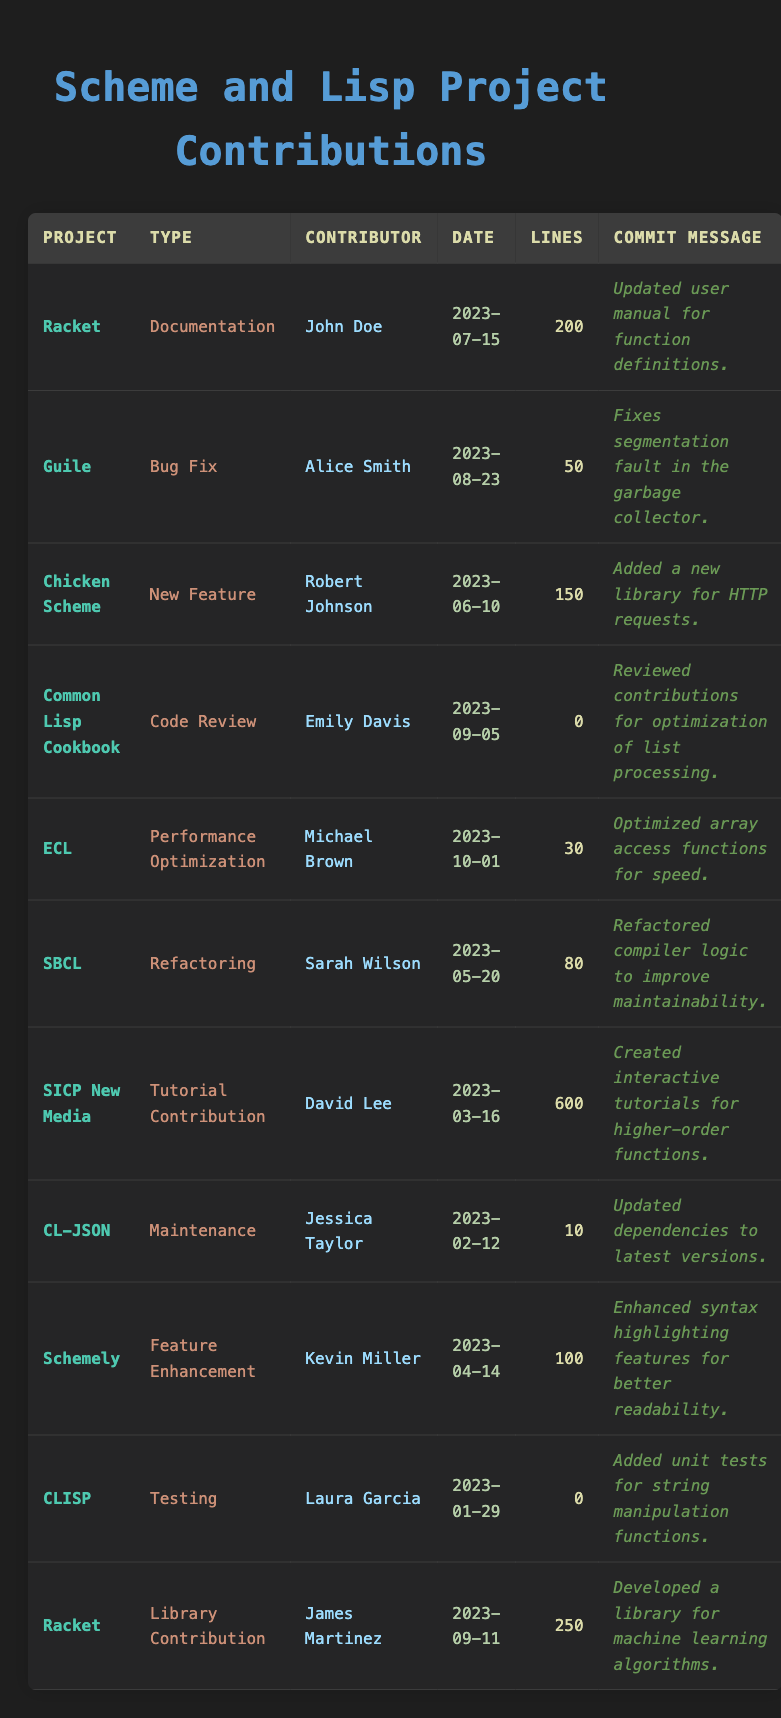What is the total number of lines contributed to the Racket project? The Racket project has two contributions: one with 200 lines and another with 250 lines. Adding these gives 200 + 250 = 450 lines of code contributed to the Racket project.
Answer: 450 Who contributed the least number of lines to any project? Looking at the contributions, Jessica Taylor for CL-JSON contributed 10 lines, while Emily Davis and Laura Garcia contributed 0 lines (as they did code reviews and testing with no line contributions). Hence, Laura Garcia shares the least with no lines.
Answer: Laura Garcia What type of contribution did Robert Johnson make? Looking at the table, Robert Johnson made a "New Feature" contribution for the Chicken Scheme project on June 10, 2023.
Answer: New Feature Did any contributor focus solely on documentation related contributions? John Doe and James Martinez both contributed to documentation tasks, but John Doe is the only one who focused solely on it with only one entry for "Documentation" in Racket.
Answer: Yes What is the average number of lines contributed across all projects? Adding up all the lines contributed (600 + 200 + 50 + 150 + 0 + 30 + 80 + 0 + 10 + 100 + 0 + 250) equals 1,270. There are 12 contributions in total, so the average is 1270 / 12 ≈ 105.83.
Answer: 105.83 Which project had the highest single line contribution? The entry for SICP New Media shows the highest singular contribution with 600 lines contributed by David Lee.
Answer: SICP New Media How many contributions were made in the year 2023? By reviewing the contribution dates, all listed contributions are from the year 2023, which totals to 12 contributions.
Answer: 12 How many unique contributors worked on projects? By scanning the list, we find that there are 10 unique contributors: John Doe, Alice Smith, Robert Johnson, Emily Davis, Michael Brown, Sarah Wilson, David Lee, Jessica Taylor, Kevin Miller, and Laura Garcia.
Answer: 10 Was there any contribution type that had no lines added? Yes, both "Code Review" by Emily Davis for the Common Lisp Cookbook and "Testing" by Laura Garcia for CLISP contributed 0 lines of code.
Answer: Yes 